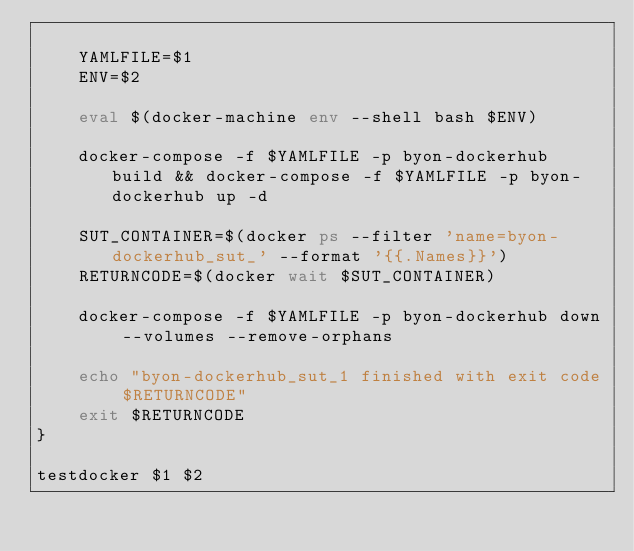Convert code to text. <code><loc_0><loc_0><loc_500><loc_500><_Bash_>
    YAMLFILE=$1
    ENV=$2

    eval $(docker-machine env --shell bash $ENV)

    docker-compose -f $YAMLFILE -p byon-dockerhub build && docker-compose -f $YAMLFILE -p byon-dockerhub up -d

    SUT_CONTAINER=$(docker ps --filter 'name=byon-dockerhub_sut_' --format '{{.Names}}')
    RETURNCODE=$(docker wait $SUT_CONTAINER)

    docker-compose -f $YAMLFILE -p byon-dockerhub down --volumes --remove-orphans

    echo "byon-dockerhub_sut_1 finished with exit code $RETURNCODE"
    exit $RETURNCODE
}

testdocker $1 $2
</code> 